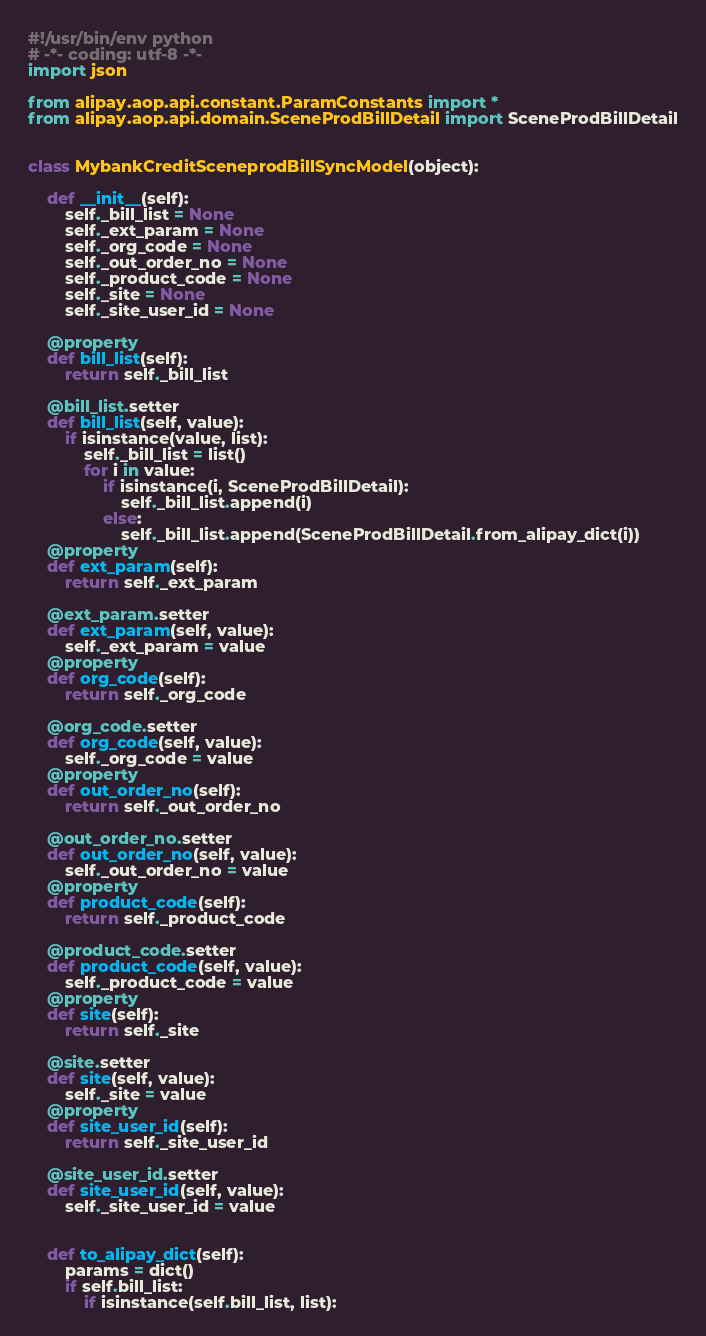Convert code to text. <code><loc_0><loc_0><loc_500><loc_500><_Python_>#!/usr/bin/env python
# -*- coding: utf-8 -*-
import json

from alipay.aop.api.constant.ParamConstants import *
from alipay.aop.api.domain.SceneProdBillDetail import SceneProdBillDetail


class MybankCreditSceneprodBillSyncModel(object):

    def __init__(self):
        self._bill_list = None
        self._ext_param = None
        self._org_code = None
        self._out_order_no = None
        self._product_code = None
        self._site = None
        self._site_user_id = None

    @property
    def bill_list(self):
        return self._bill_list

    @bill_list.setter
    def bill_list(self, value):
        if isinstance(value, list):
            self._bill_list = list()
            for i in value:
                if isinstance(i, SceneProdBillDetail):
                    self._bill_list.append(i)
                else:
                    self._bill_list.append(SceneProdBillDetail.from_alipay_dict(i))
    @property
    def ext_param(self):
        return self._ext_param

    @ext_param.setter
    def ext_param(self, value):
        self._ext_param = value
    @property
    def org_code(self):
        return self._org_code

    @org_code.setter
    def org_code(self, value):
        self._org_code = value
    @property
    def out_order_no(self):
        return self._out_order_no

    @out_order_no.setter
    def out_order_no(self, value):
        self._out_order_no = value
    @property
    def product_code(self):
        return self._product_code

    @product_code.setter
    def product_code(self, value):
        self._product_code = value
    @property
    def site(self):
        return self._site

    @site.setter
    def site(self, value):
        self._site = value
    @property
    def site_user_id(self):
        return self._site_user_id

    @site_user_id.setter
    def site_user_id(self, value):
        self._site_user_id = value


    def to_alipay_dict(self):
        params = dict()
        if self.bill_list:
            if isinstance(self.bill_list, list):</code> 